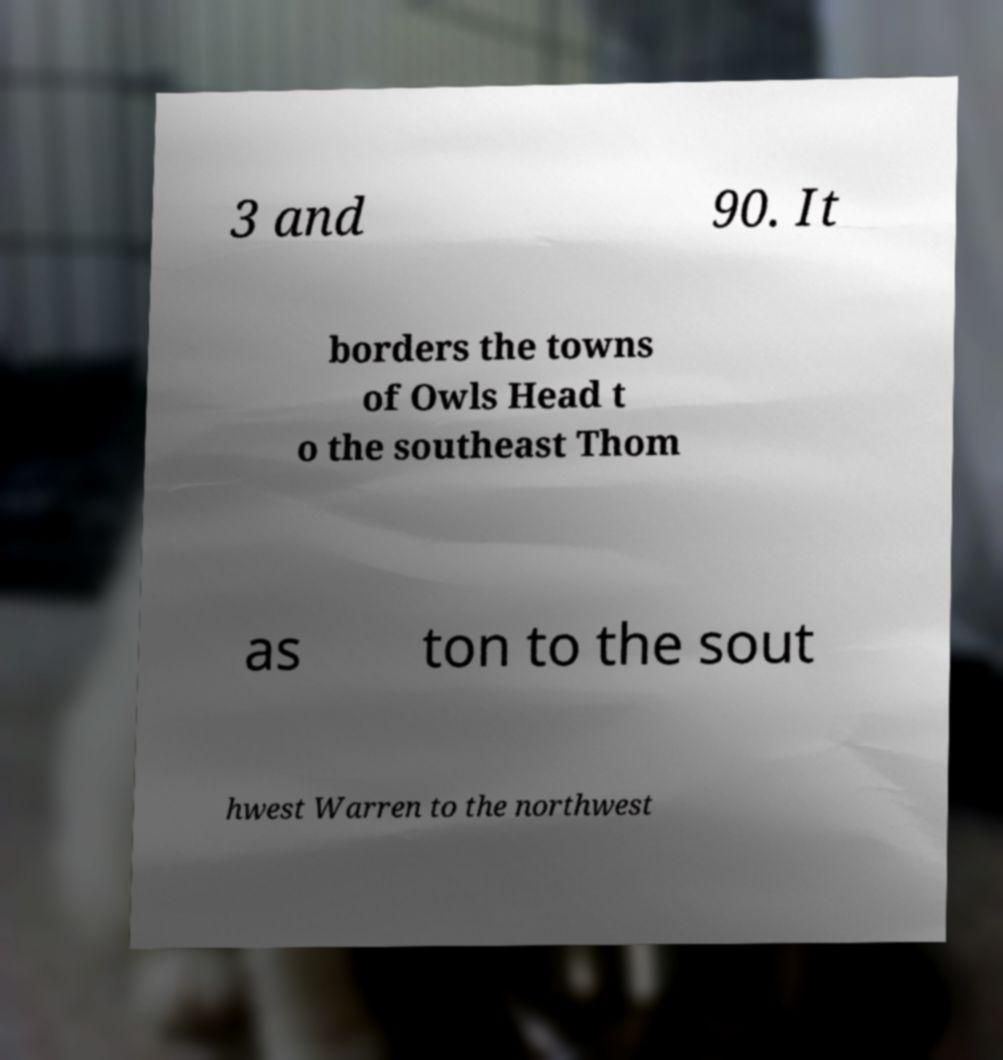Could you extract and type out the text from this image? 3 and 90. It borders the towns of Owls Head t o the southeast Thom as ton to the sout hwest Warren to the northwest 